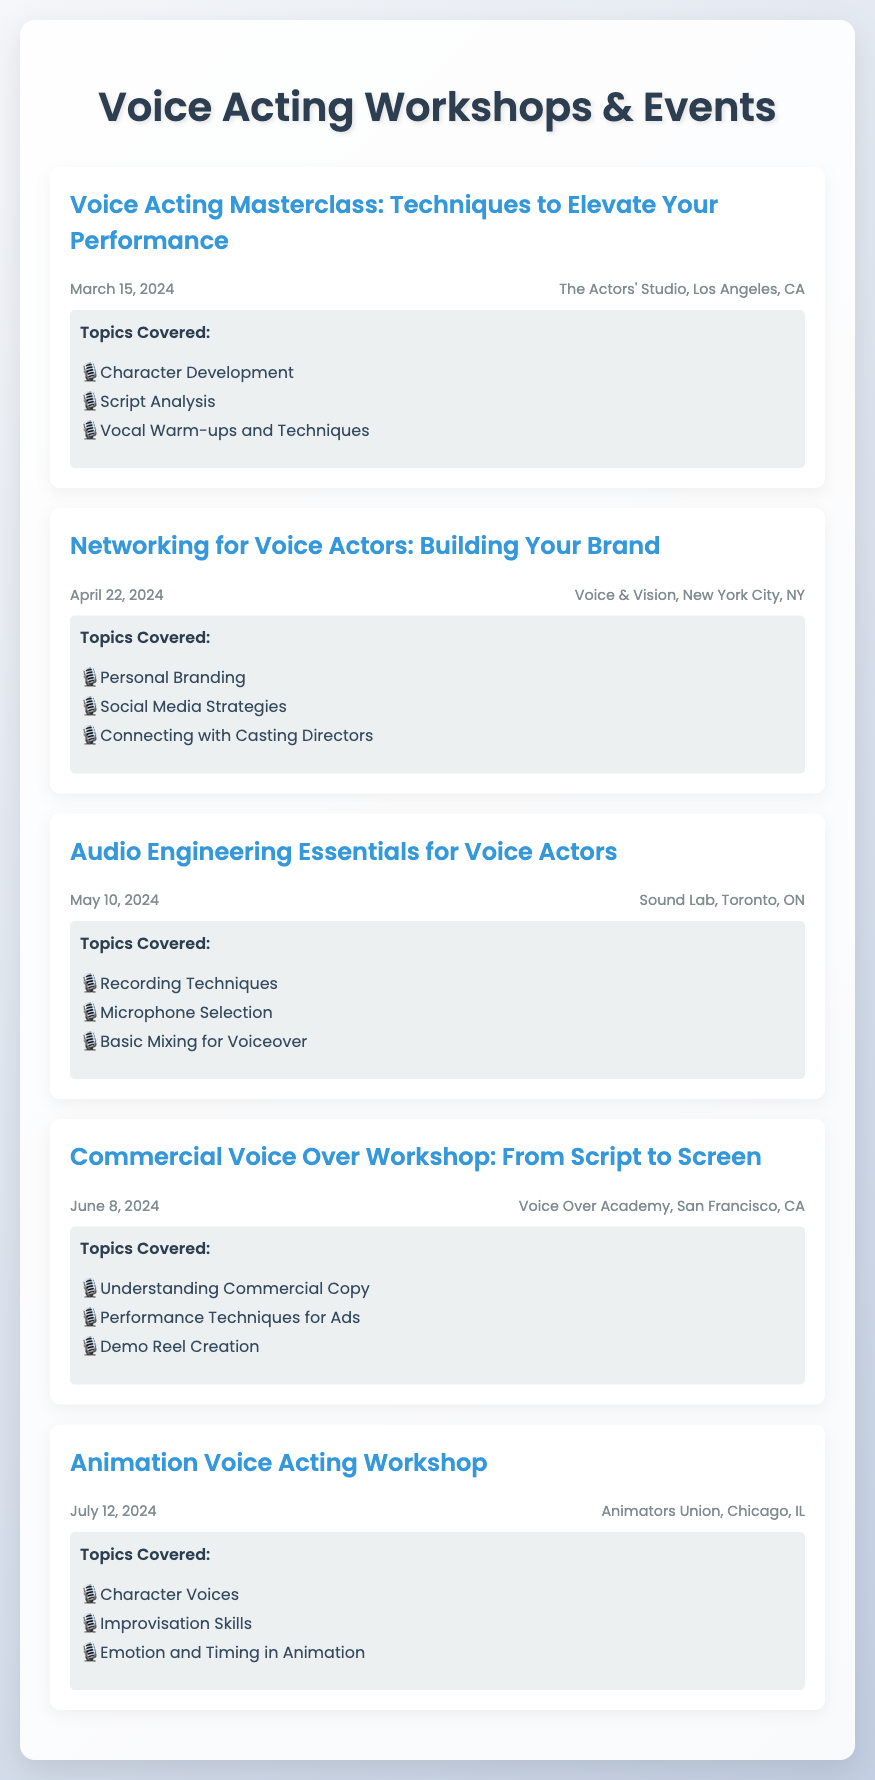What is the date of the Voice Acting Masterclass? The date is specifically stated in the document as March 15, 2024.
Answer: March 15, 2024 Where is the Networking for Voice Actors event located? The location is mentioned in the document, found in the event details for this specific workshop.
Answer: Voice & Vision, New York City, NY What are the topics covered in the Audio Engineering Essentials workshop? The topics are listed under the topics covered section of the event.
Answer: Recording Techniques, Microphone Selection, Basic Mixing for Voiceover How many workshops are scheduled before July 2024? The document lists events, allowing for a count of those scheduled up to the specified date.
Answer: Five What is the title of the workshop on June 8, 2024? This title is clearly outlined in the event title section of that particular event.
Answer: Commercial Voice Over Workshop: From Script to Screen What is the main focus of the Animation Voice Acting Workshop? This can be inferred from the topics covered in the document about this specific event.
Answer: Character Voices, Improvisation Skills, Emotion and Timing in Animation Which city hosts the Audio Engineering Essentials workshop? The location details will guide you to the specific city hosting that workshop as mentioned in the document.
Answer: Toronto, ON What skill is emphasized in the Networking for Voice Actors event? The document indicates this focus in the topics covered for that event.
Answer: Personal Branding 